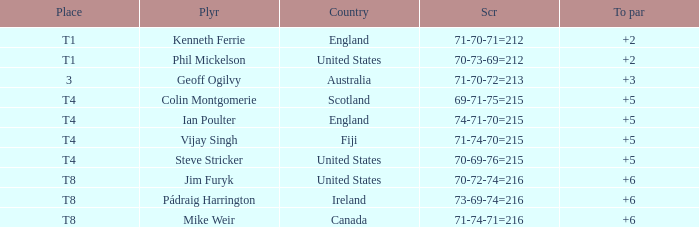Who had a score of 70-73-69=212? Phil Mickelson. 